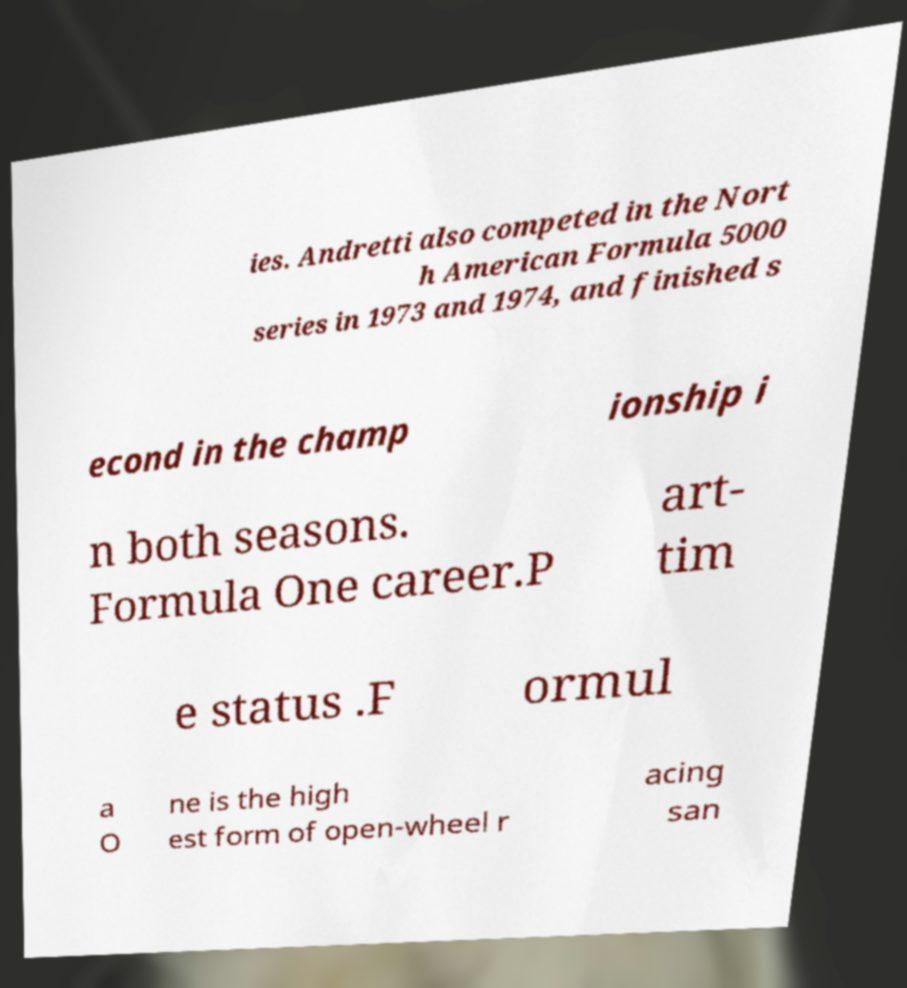Please read and relay the text visible in this image. What does it say? ies. Andretti also competed in the Nort h American Formula 5000 series in 1973 and 1974, and finished s econd in the champ ionship i n both seasons. Formula One career.P art- tim e status .F ormul a O ne is the high est form of open-wheel r acing san 